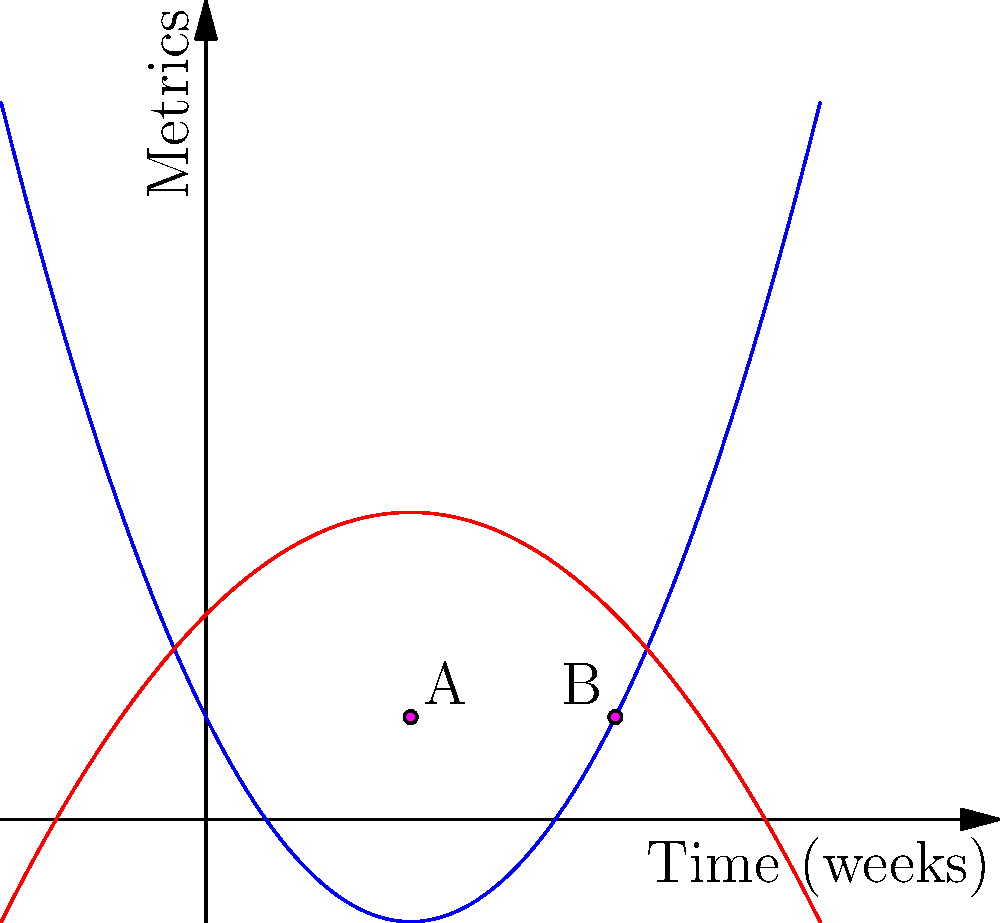As a game developer, you're analyzing two key metrics: Daily Active Users (DAU) and In-Game Purchases (IGP) over time. The blue curve represents DAU, given by the function $f(x) = 0.5x^2 - 2x + 1$, and the red curve represents IGP, given by $g(x) = -0.25x^2 + x + 2$, where $x$ is time in weeks. At how many points do these curves intersect, and what are the $x$-coordinates of these intersections? To find the intersections, we need to solve the equation $f(x) = g(x)$:

1) Set up the equation:
   $0.5x^2 - 2x + 1 = -0.25x^2 + x + 2$

2) Rearrange to standard form:
   $0.5x^2 + 0.25x^2 - 2x - x + 1 - 2 = 0$
   $0.75x^2 - 3x - 1 = 0$

3) Multiply all terms by 4 to eliminate fractions:
   $3x^2 - 12x - 4 = 0$

4) This is a quadratic equation. We can solve it using the quadratic formula:
   $x = \frac{-b \pm \sqrt{b^2 - 4ac}}{2a}$
   Where $a = 3$, $b = -12$, and $c = -4$

5) Plugging in the values:
   $x = \frac{12 \pm \sqrt{(-12)^2 - 4(3)(-4)}}{2(3)}$
   $= \frac{12 \pm \sqrt{144 + 48}}{6}$
   $= \frac{12 \pm \sqrt{192}}{6}$
   $= \frac{12 \pm 8\sqrt{3}}{6}$

6) Simplifying:
   $x = 2 \pm \frac{4\sqrt{3}}{3}$

7) This gives us two solutions:
   $x_1 = 2 + \frac{4\sqrt{3}}{3} \approx 4$
   $x_2 = 2 - \frac{4\sqrt{3}}{3} \approx 2$

Therefore, the curves intersect at two points, with x-coordinates of approximately 2 and 4 weeks.
Answer: 2 intersections; x ≈ 2 and 4 weeks 